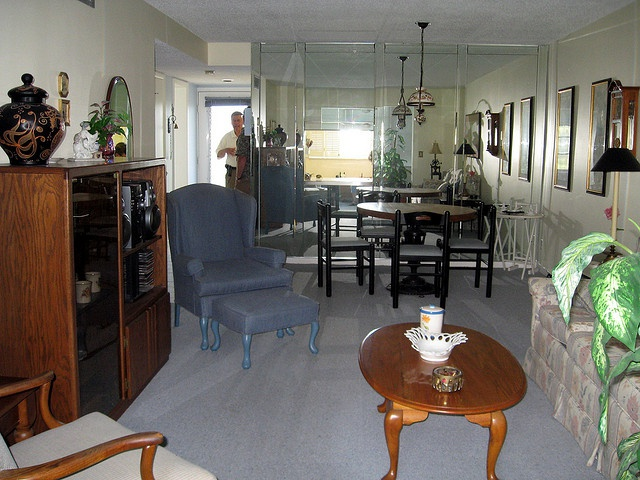Describe the objects in this image and their specific colors. I can see couch in darkgray, gray, and green tones, chair in darkgray, black, maroon, and brown tones, chair in darkgray, black, darkblue, and gray tones, potted plant in darkgray, green, beige, and lightgreen tones, and chair in darkgray, black, and gray tones in this image. 